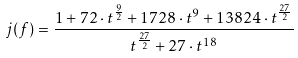<formula> <loc_0><loc_0><loc_500><loc_500>j ( f ) = \frac { 1 + 7 2 \cdot t ^ { \frac { 9 } { 2 } } + 1 7 2 8 \cdot t ^ { 9 } + 1 3 8 2 4 \cdot t ^ { \frac { 2 7 } { 2 } } } { t ^ { \frac { 2 7 } { 2 } } + 2 7 \cdot t ^ { 1 8 } }</formula> 